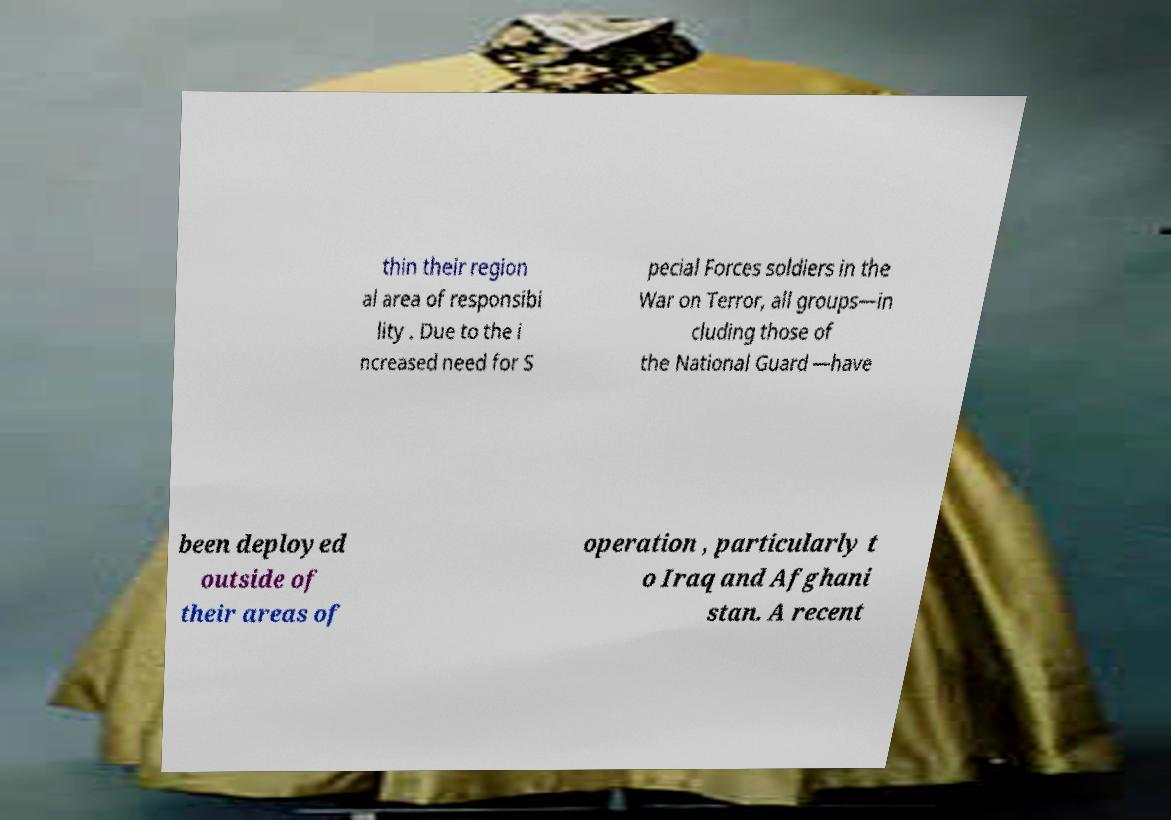Could you extract and type out the text from this image? thin their region al area of responsibi lity . Due to the i ncreased need for S pecial Forces soldiers in the War on Terror, all groups—in cluding those of the National Guard —have been deployed outside of their areas of operation , particularly t o Iraq and Afghani stan. A recent 